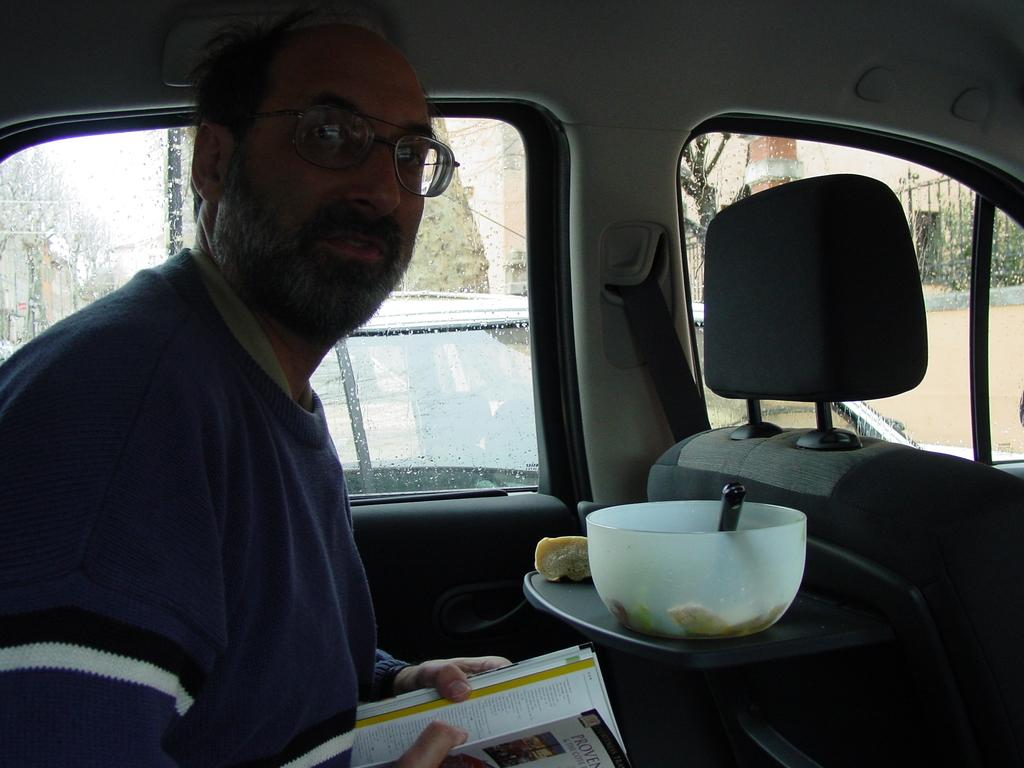What is the person inside the car doing? The person is sitting inside the car and holding a book. What object is in front of the person? There is a bowl in front of the person. What type of marble is visible on the floor of the car? There is no marble visible on the floor of the car in the image. How many ducks are present in the car? There are no ducks present in the car in the image. 